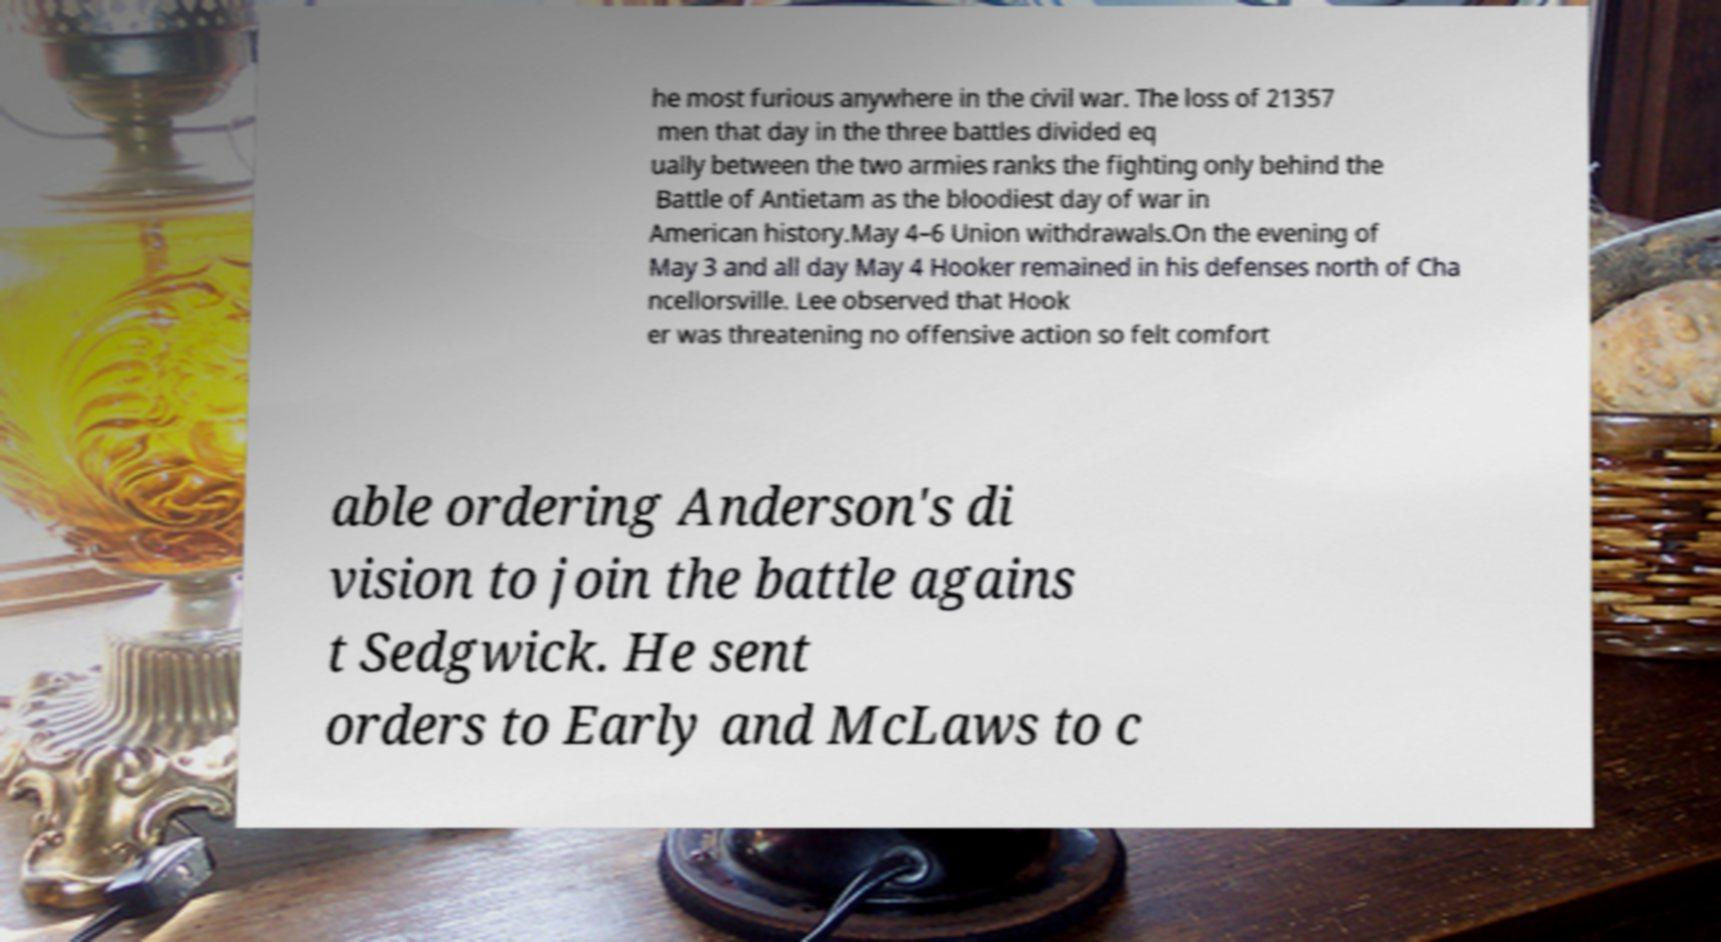What messages or text are displayed in this image? I need them in a readable, typed format. he most furious anywhere in the civil war. The loss of 21357 men that day in the three battles divided eq ually between the two armies ranks the fighting only behind the Battle of Antietam as the bloodiest day of war in American history.May 4–6 Union withdrawals.On the evening of May 3 and all day May 4 Hooker remained in his defenses north of Cha ncellorsville. Lee observed that Hook er was threatening no offensive action so felt comfort able ordering Anderson's di vision to join the battle agains t Sedgwick. He sent orders to Early and McLaws to c 